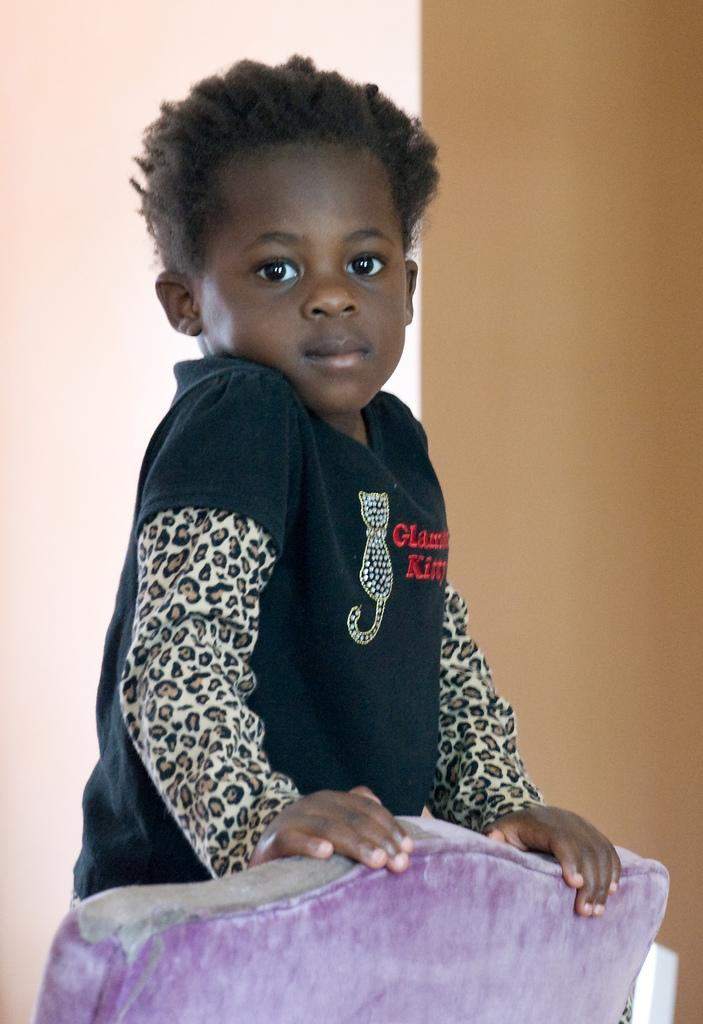Who is the main subject in the image? There is a boy in the image. What is the boy doing in the image? The boy is looking to his side. What is the boy wearing in the image? The boy is wearing a black t-shirt. What part of the boy's body is painted in a different color in the image? There is no indication in the image that any part of the boy's body is painted in a different color. 